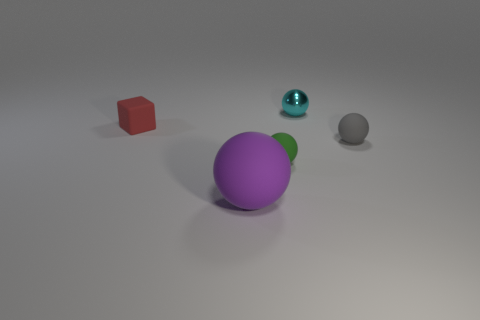Subtract 1 spheres. How many spheres are left? 3 Add 1 big spheres. How many objects exist? 6 Subtract all spheres. How many objects are left? 1 Subtract 0 yellow spheres. How many objects are left? 5 Subtract all red blocks. Subtract all purple things. How many objects are left? 3 Add 4 small balls. How many small balls are left? 7 Add 5 big matte things. How many big matte things exist? 6 